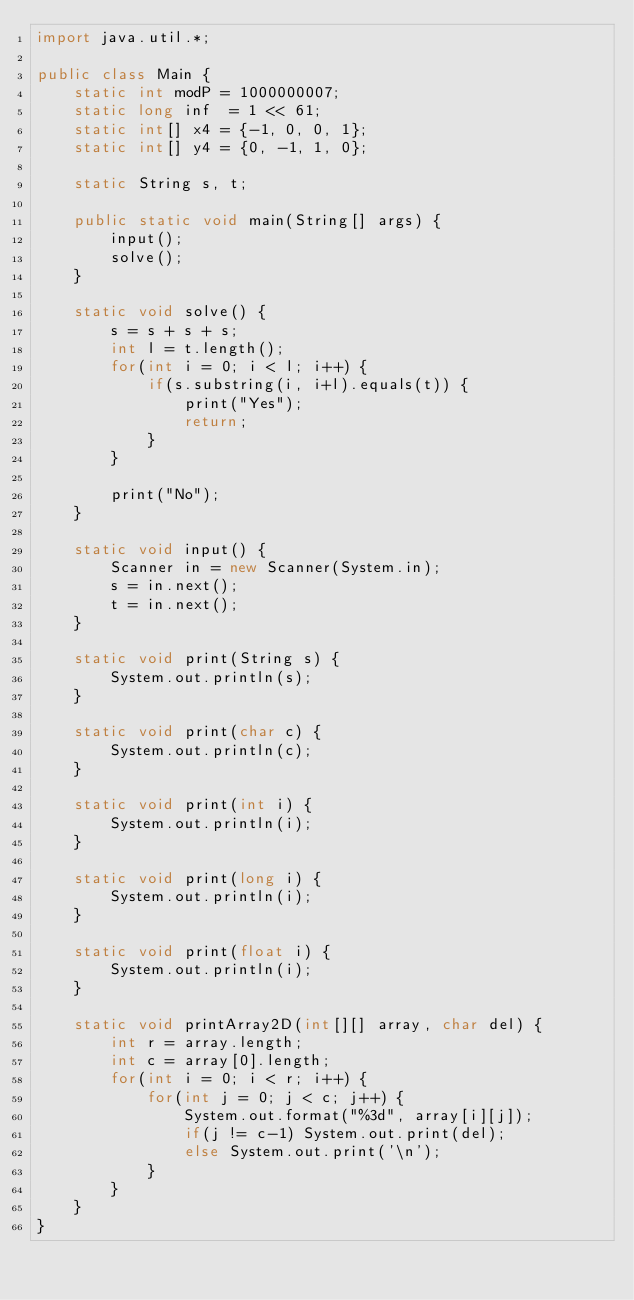<code> <loc_0><loc_0><loc_500><loc_500><_Java_>import java.util.*;

public class Main {
    static int modP = 1000000007;
    static long inf  = 1 << 61;
    static int[] x4 = {-1, 0, 0, 1};
    static int[] y4 = {0, -1, 1, 0};

    static String s, t;

    public static void main(String[] args) {
        input();
        solve();
    }

    static void solve() {
        s = s + s + s;
        int l = t.length();
        for(int i = 0; i < l; i++) {
            if(s.substring(i, i+l).equals(t)) {
                print("Yes");
                return;
            }
        }

        print("No");
    }

    static void input() {
        Scanner in = new Scanner(System.in);
        s = in.next();
        t = in.next();
    }

    static void print(String s) {
        System.out.println(s);
    }

    static void print(char c) {
        System.out.println(c);
    }

    static void print(int i) {
        System.out.println(i);
    }

    static void print(long i) {
        System.out.println(i);
    }

    static void print(float i) {
        System.out.println(i);
    }

    static void printArray2D(int[][] array, char del) {
        int r = array.length;
        int c = array[0].length;
        for(int i = 0; i < r; i++) {
            for(int j = 0; j < c; j++) {
                System.out.format("%3d", array[i][j]);
                if(j != c-1) System.out.print(del);
                else System.out.print('\n');
            }
        }
    }
}</code> 